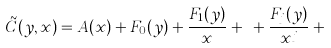<formula> <loc_0><loc_0><loc_500><loc_500>\tilde { C } ( y , x ) = A ( x ) + F _ { 0 } ( y ) + \frac { F _ { 1 } ( y ) } { x } + \cdots + \frac { F _ { j } ( y ) } { x ^ { j } } + \cdots</formula> 